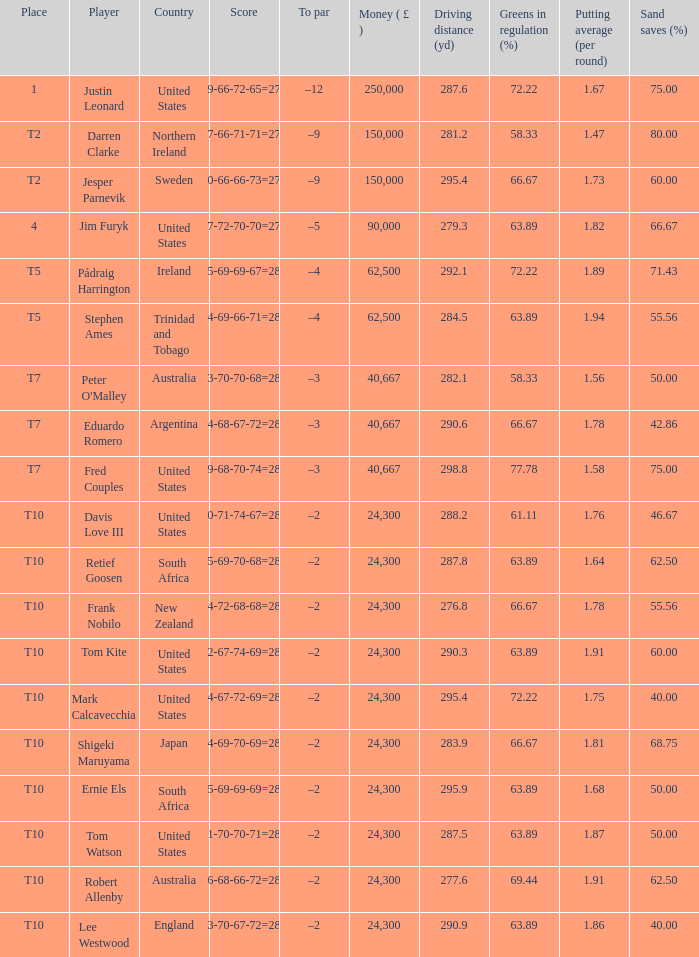What is Lee Westwood's score? 73-70-67-72=282. 